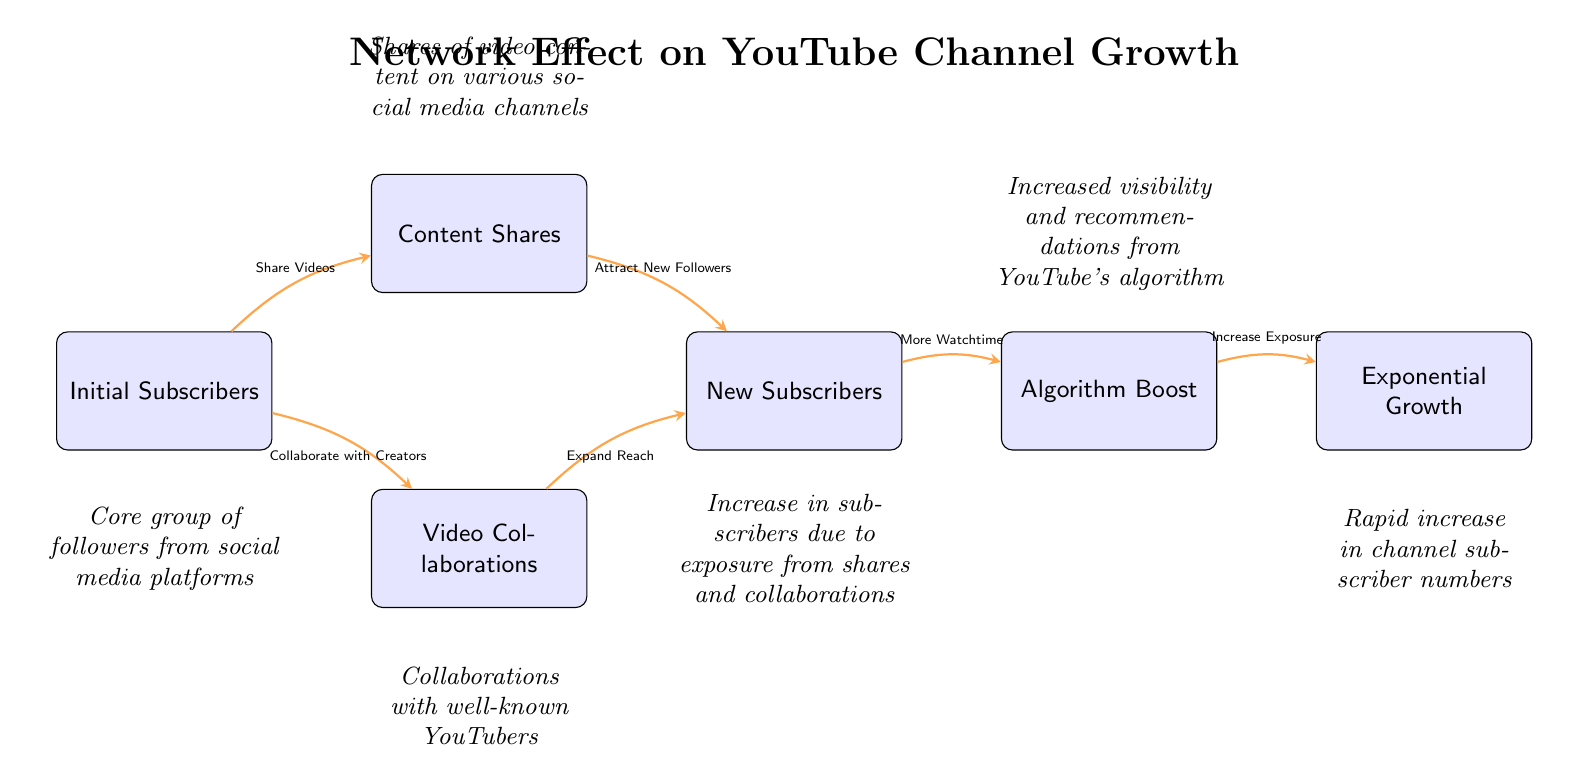What are the three initial inputs for subscriber growth? The diagram shows three initial inputs: Initial Subscribers, Content Shares, and Video Collaborations, which all contribute to growth.
Answer: Initial Subscribers, Content Shares, Video Collaborations How many primary nodes are there in the diagram? By counting the distinct nodes in the diagram, we identify six primary nodes: Initial Subscribers, Content Shares, Video Collaborations, New Subscribers, Algorithm Boost, and Exponential Growth.
Answer: Six What is the output of the flow from `Content Shares` to `New Subscribers`? The edge from Content Shares to New Subscribers indicates that shares of video content attract new followers, thereby increasing the number of subscribers.
Answer: Attract New Followers Which node directly affects `Exponential Growth`? The edge from Algorithm Boost to Exponential Growth indicates that increased visibility and recommendations from YouTube's algorithm directly affect exponential growth.
Answer: Algorithm Boost What is the relationship between `Initial Subscribers` and `Video Collaborations`? The edge from Initial Subscribers to Video Collaborations signifies that collaborating with creators can be initiated by the core group of existing subscribers, indicating their role in fostering collaborations.
Answer: Collaborate with Creators What effect does `Video Collaborations` have on `New Subscribers`? The edge from Video Collaborations to New Subscribers shows that collaborations expand reach and help in attracting new subscribers.
Answer: Expand Reach What role does the `Algorithm Boost` play in subscriber growth? The edge leading from Algorithm Boost to Exponential Growth highlights that more watch time from new subscribers leads to algorithmic recognition, enhancing exposure.
Answer: Increase Exposure What is the flow of influence in the first step of this network effect? The first step starts with Initial Subscribers sharing videos, leading to Content Shares which then go on to attract new followers, demonstrating a sequential influence that builds initial momentum.
Answer: Share Videos 